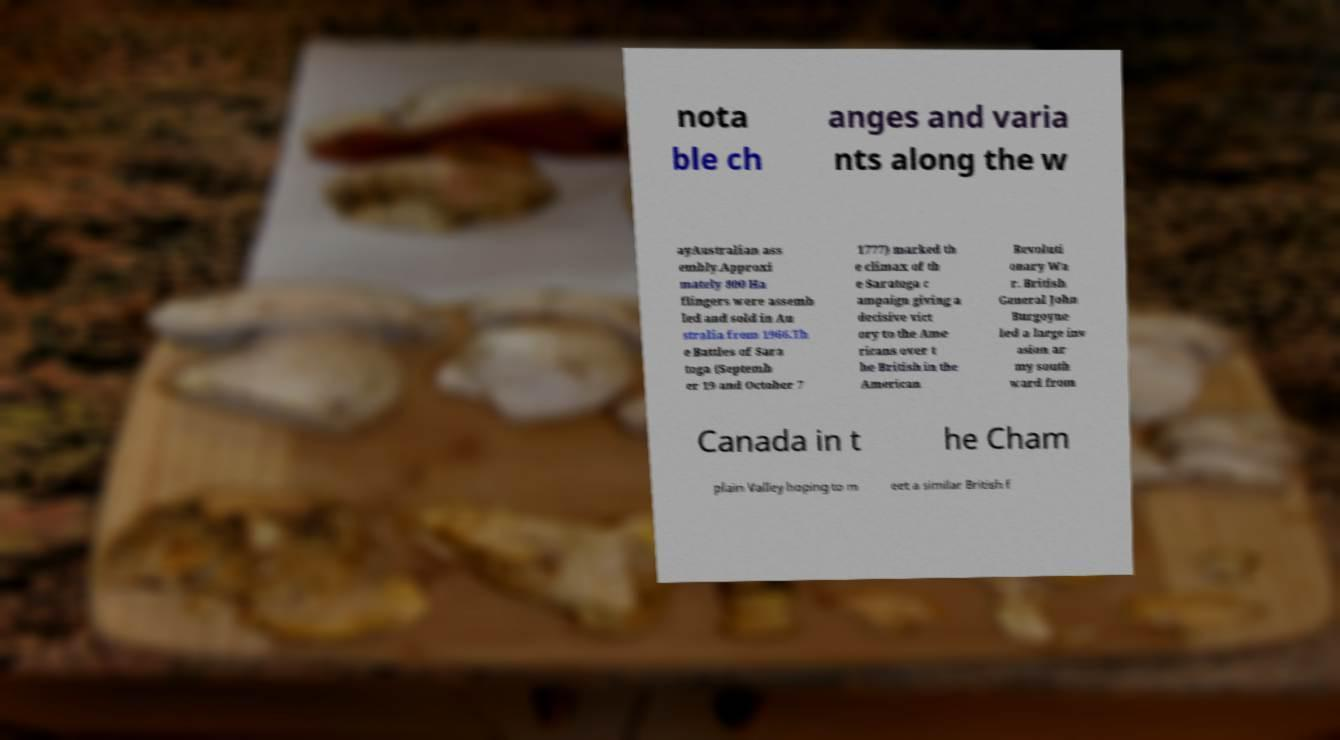Can you accurately transcribe the text from the provided image for me? nota ble ch anges and varia nts along the w ayAustralian ass embly.Approxi mately 800 Ha flingers were assemb led and sold in Au stralia from 1966.Th e Battles of Sara toga (Septemb er 19 and October 7 1777) marked th e climax of th e Saratoga c ampaign giving a decisive vict ory to the Ame ricans over t he British in the American Revoluti onary Wa r. British General John Burgoyne led a large inv asion ar my south ward from Canada in t he Cham plain Valley hoping to m eet a similar British f 